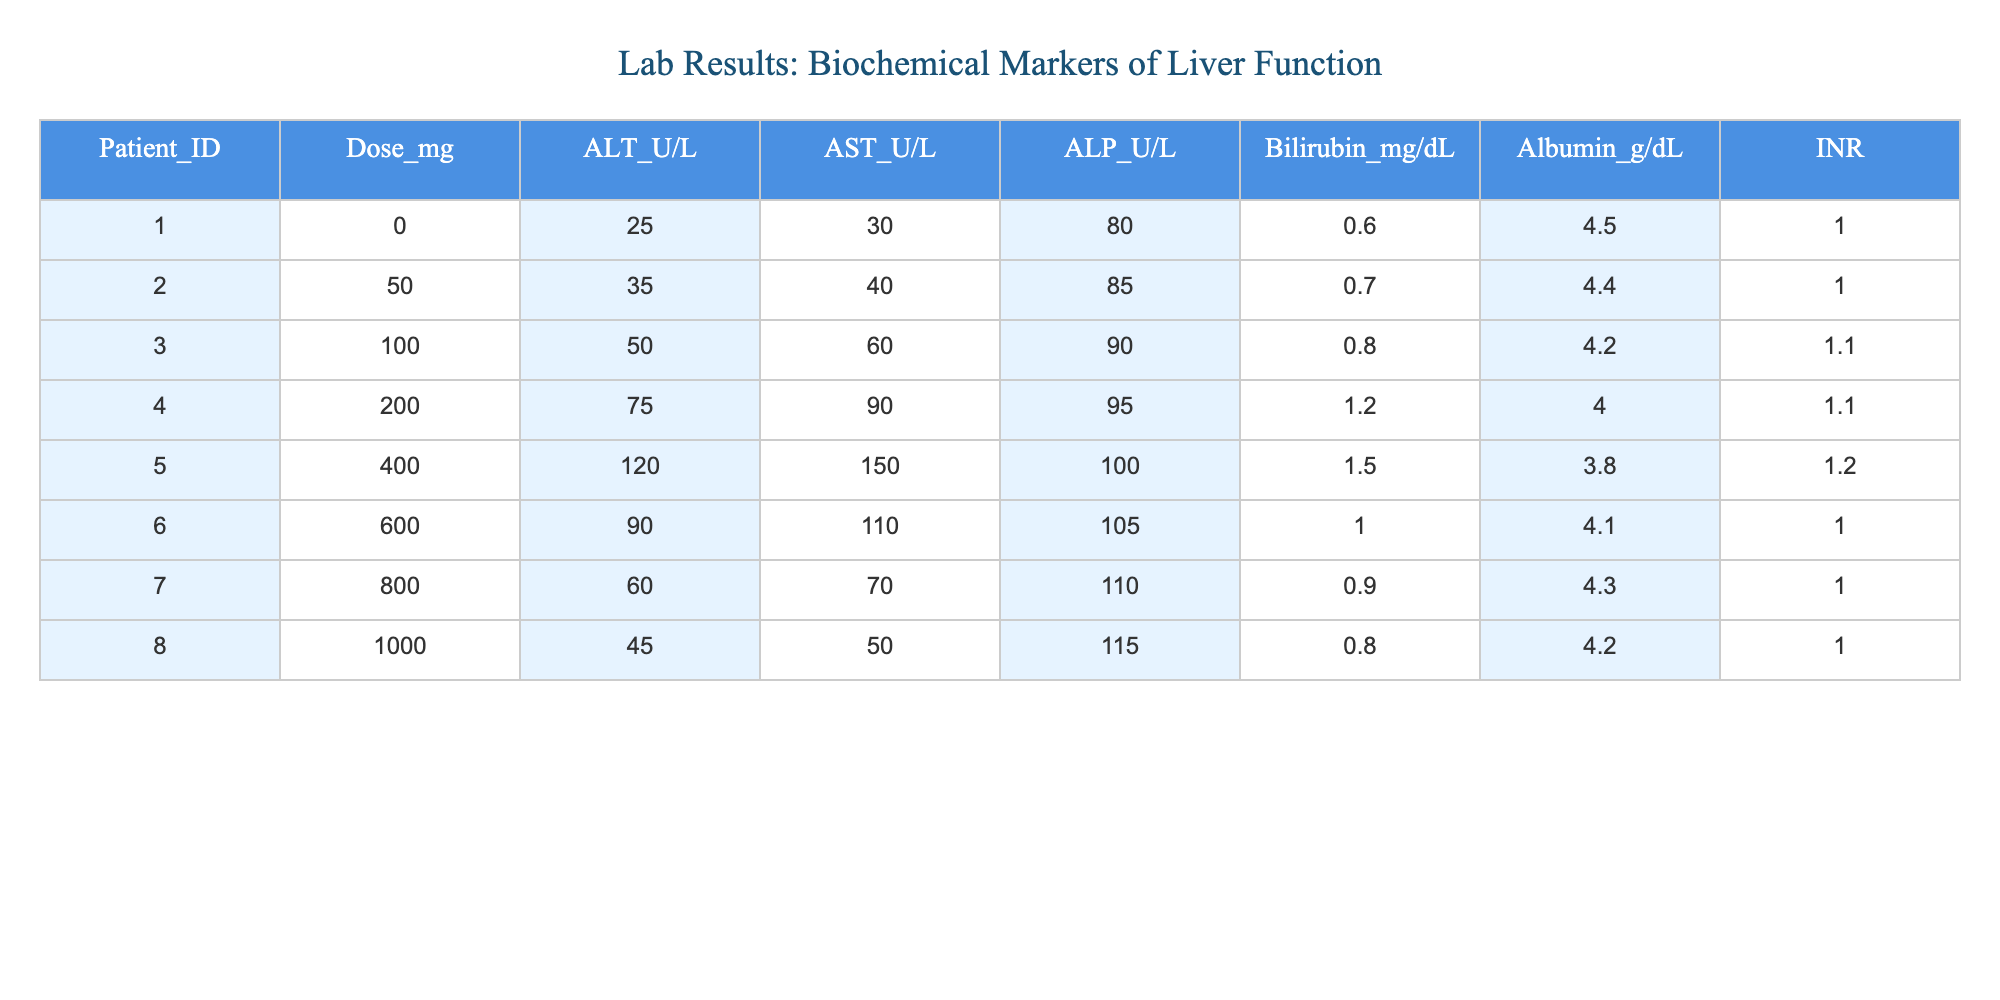What is the ALT level for patient 005? According to the table, the ALT level for patient 005 is 120 U/L. This value is directly retrievable from the corresponding row for patient 005.
Answer: 120 U/L What is the highest dose administered among the patients? Reviewing the doses listed in the table, the highest dose is 1000 mg for patient 008. This value was checked by comparing the Dose_mg column for all patients.
Answer: 1000 mg What is the average Bilirubin level for all patients? To calculate the average Bilirubin level, sum all the Bilirubin values: (0.6 + 0.7 + 0.8 + 1.2 + 1.5 + 1.0 + 0.9 + 0.8) = 6.5 mg/dL. Then, divide by the number of patients (8): 6.5 / 8 = 0.8125 mg/dL. So, the average is approximately 0.81 mg/dL.
Answer: 0.81 mg/dL Are there any patients with an AST level greater than 100 U/L? Yes, comparing the AST levels across all patients, patient 005 has an AST level of 150 U/L, which is greater than 100 U/L. Therefore, the answer to this question is yes.
Answer: Yes Which patient has the lowest Albumin level and what is that level? The patient with the lowest Albumin level is patient 005 with a level of 3.8 g/dL. This information can be found by scanning through the Albumin_g/dL column and identifying the minimum value.
Answer: 3.8 g/dL What is the difference in the ALT levels between the highest and lowest doses? The lowest dose is 0 mg (patient 001) with an ALT of 25 U/L, and the highest dose is 1000 mg (patient 008) with an ALT of 45 U/L. The difference is calculated as 45 U/L - 25 U/L = 20 U/L.
Answer: 20 U/L Is the INR value for patient 006 higher than 1.0? No, the INR value for patient 006 is 1.0, so it is not higher than 1.0. This fact can be verified by looking at the INR column specifically for patient 006.
Answer: No What are the values for ALT and AST for the 200 mg dose? For the 200 mg dose (patient 004), the ALT level is 75 U/L and the AST level is 90 U/L. These values can be accessed directly from the respective columns for patient 004.
Answer: ALT: 75 U/L, AST: 90 U/L 